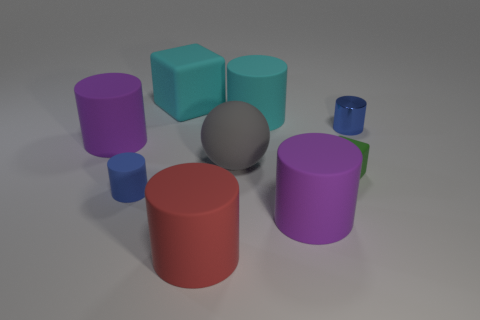There is a big gray rubber thing; is it the same shape as the purple matte thing behind the large gray thing?
Provide a short and direct response. No. Are there fewer tiny green cubes behind the ball than small blue objects to the right of the big cyan matte block?
Provide a succinct answer. Yes. There is a cyan object that is the same shape as the red object; what is its material?
Ensure brevity in your answer.  Rubber. Is there any other thing that has the same material as the gray thing?
Provide a succinct answer. Yes. Does the tiny metal thing have the same color as the tiny matte cube?
Keep it short and to the point. No. There is a green thing that is made of the same material as the big red cylinder; what is its shape?
Your response must be concise. Cube. How many small green rubber objects have the same shape as the big gray rubber object?
Make the answer very short. 0. There is a purple matte object to the right of the large purple cylinder behind the small block; what is its shape?
Provide a short and direct response. Cylinder. Do the metal cylinder that is right of the gray thing and the big sphere have the same size?
Offer a terse response. No. What is the size of the rubber cylinder that is in front of the big matte sphere and left of the big red matte object?
Your answer should be very brief. Small. 